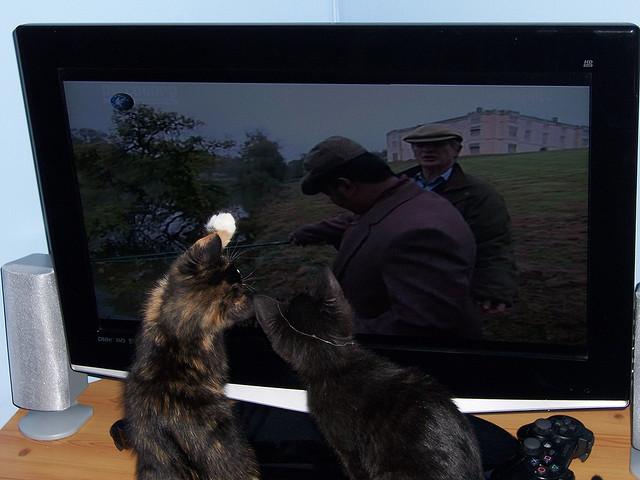Is this a movie theater for cats?
Short answer required. No. What kind of stuffed animals are there?
Short answer required. None. What are the cats looking at?
Keep it brief. Tv. Is the tv on?
Keep it brief. Yes. 